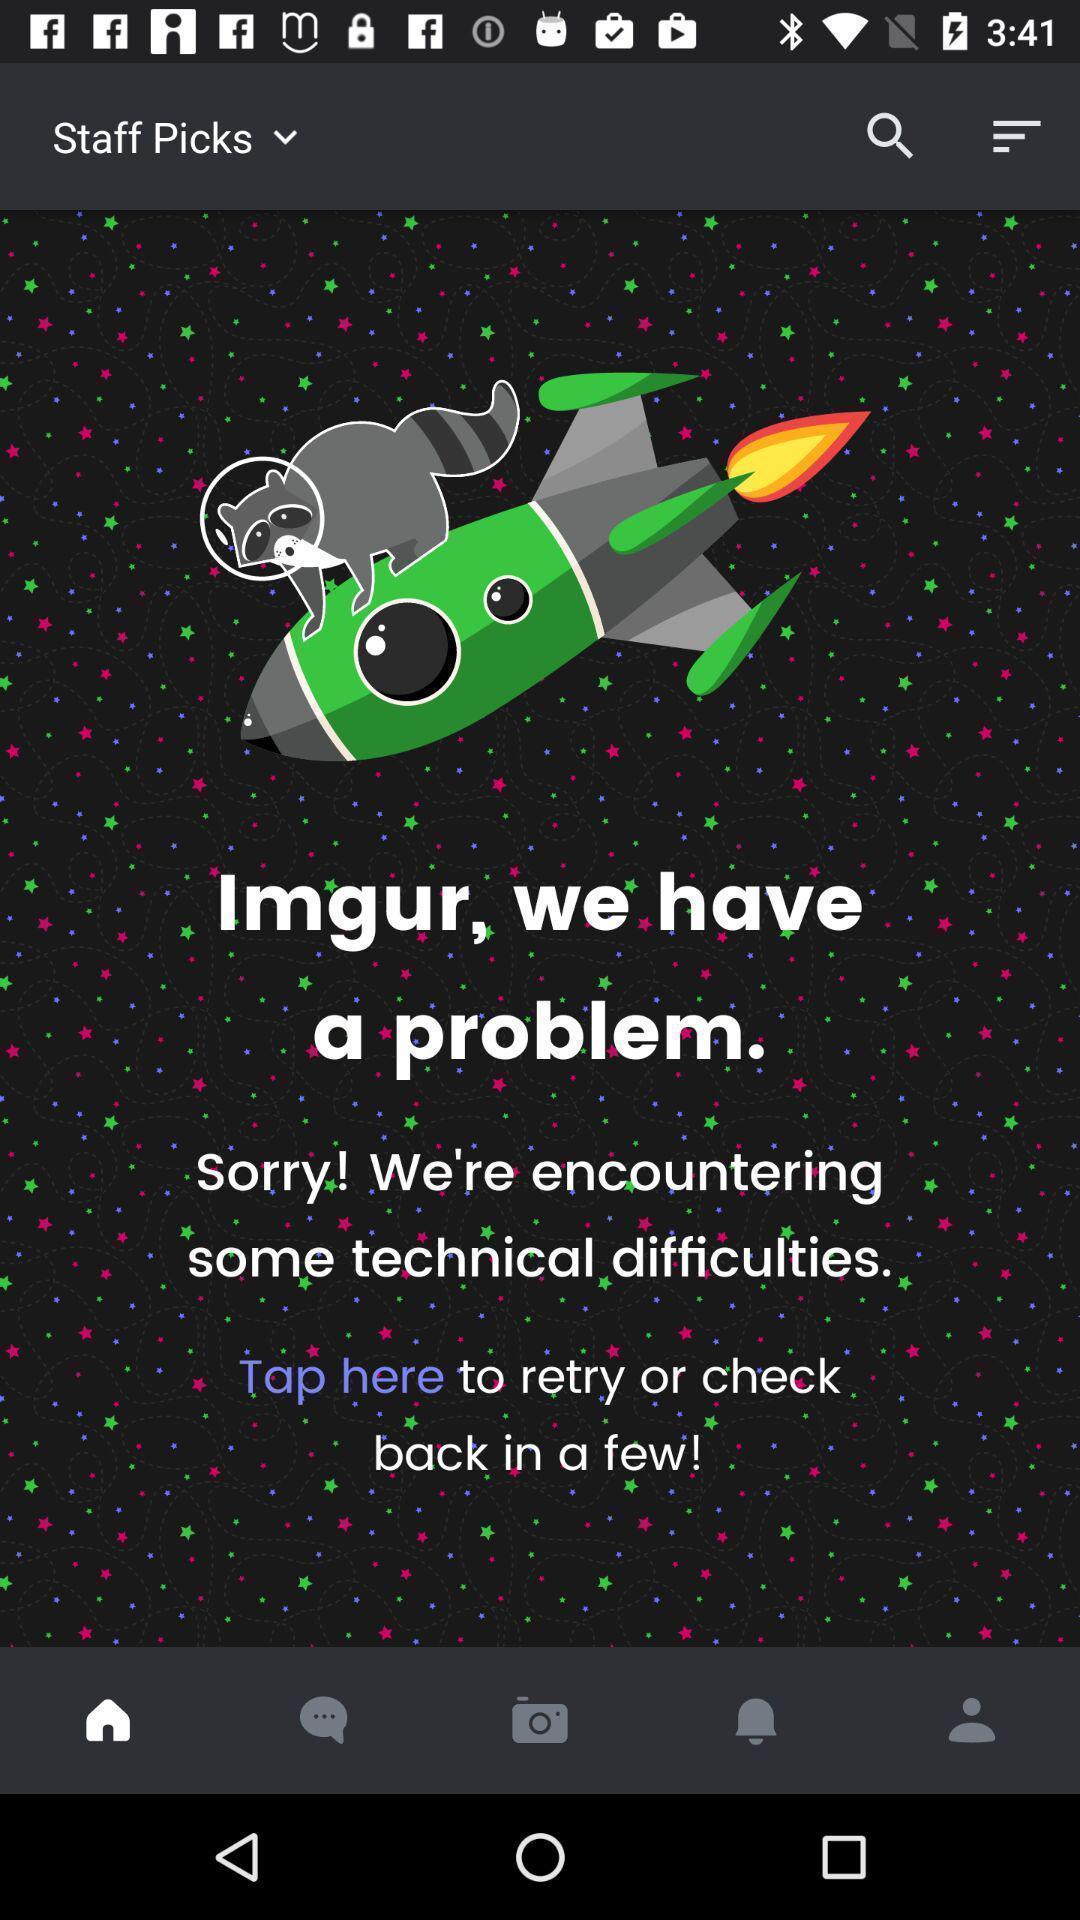What can you discern from this picture? Screen showing error message of a entertainment app. 